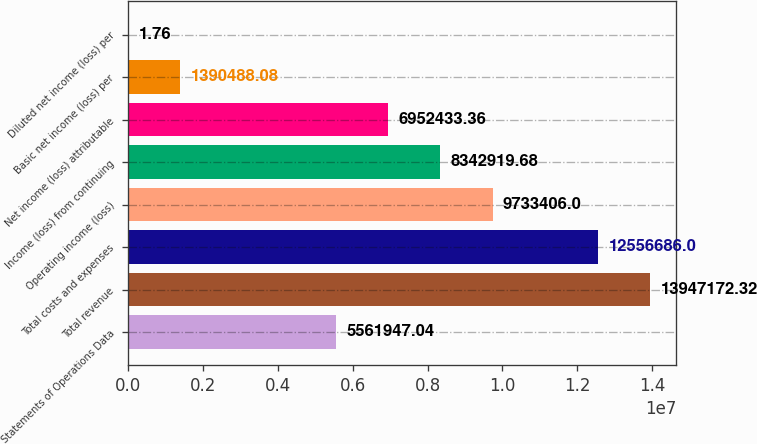Convert chart to OTSL. <chart><loc_0><loc_0><loc_500><loc_500><bar_chart><fcel>Statements of Operations Data<fcel>Total revenue<fcel>Total costs and expenses<fcel>Operating income (loss)<fcel>Income (loss) from continuing<fcel>Net income (loss) attributable<fcel>Basic net income (loss) per<fcel>Diluted net income (loss) per<nl><fcel>5.56195e+06<fcel>1.39472e+07<fcel>1.25567e+07<fcel>9.73341e+06<fcel>8.34292e+06<fcel>6.95243e+06<fcel>1.39049e+06<fcel>1.76<nl></chart> 